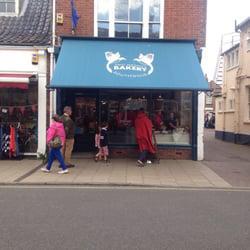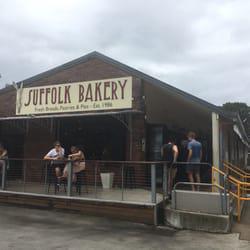The first image is the image on the left, the second image is the image on the right. Evaluate the accuracy of this statement regarding the images: "there is a brick building with a blue fabric awning, above the awning is a white painted window". Is it true? Answer yes or no. Yes. The first image is the image on the left, the second image is the image on the right. Considering the images on both sides, is "The building in one of the images has a blue awning." valid? Answer yes or no. Yes. 